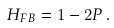<formula> <loc_0><loc_0><loc_500><loc_500>H _ { F B } = 1 - 2 P \, .</formula> 